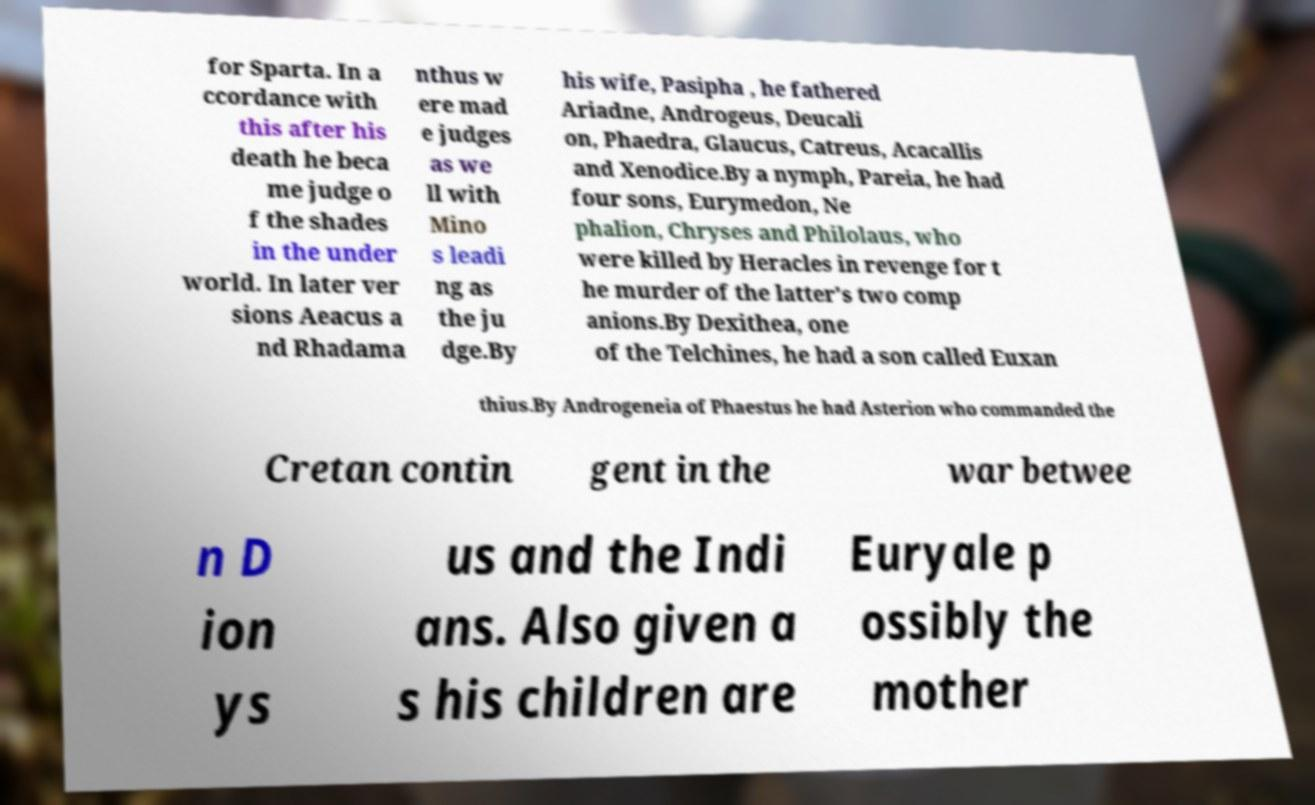What messages or text are displayed in this image? I need them in a readable, typed format. for Sparta. In a ccordance with this after his death he beca me judge o f the shades in the under world. In later ver sions Aeacus a nd Rhadama nthus w ere mad e judges as we ll with Mino s leadi ng as the ju dge.By his wife, Pasipha , he fathered Ariadne, Androgeus, Deucali on, Phaedra, Glaucus, Catreus, Acacallis and Xenodice.By a nymph, Pareia, he had four sons, Eurymedon, Ne phalion, Chryses and Philolaus, who were killed by Heracles in revenge for t he murder of the latter's two comp anions.By Dexithea, one of the Telchines, he had a son called Euxan thius.By Androgeneia of Phaestus he had Asterion who commanded the Cretan contin gent in the war betwee n D ion ys us and the Indi ans. Also given a s his children are Euryale p ossibly the mother 